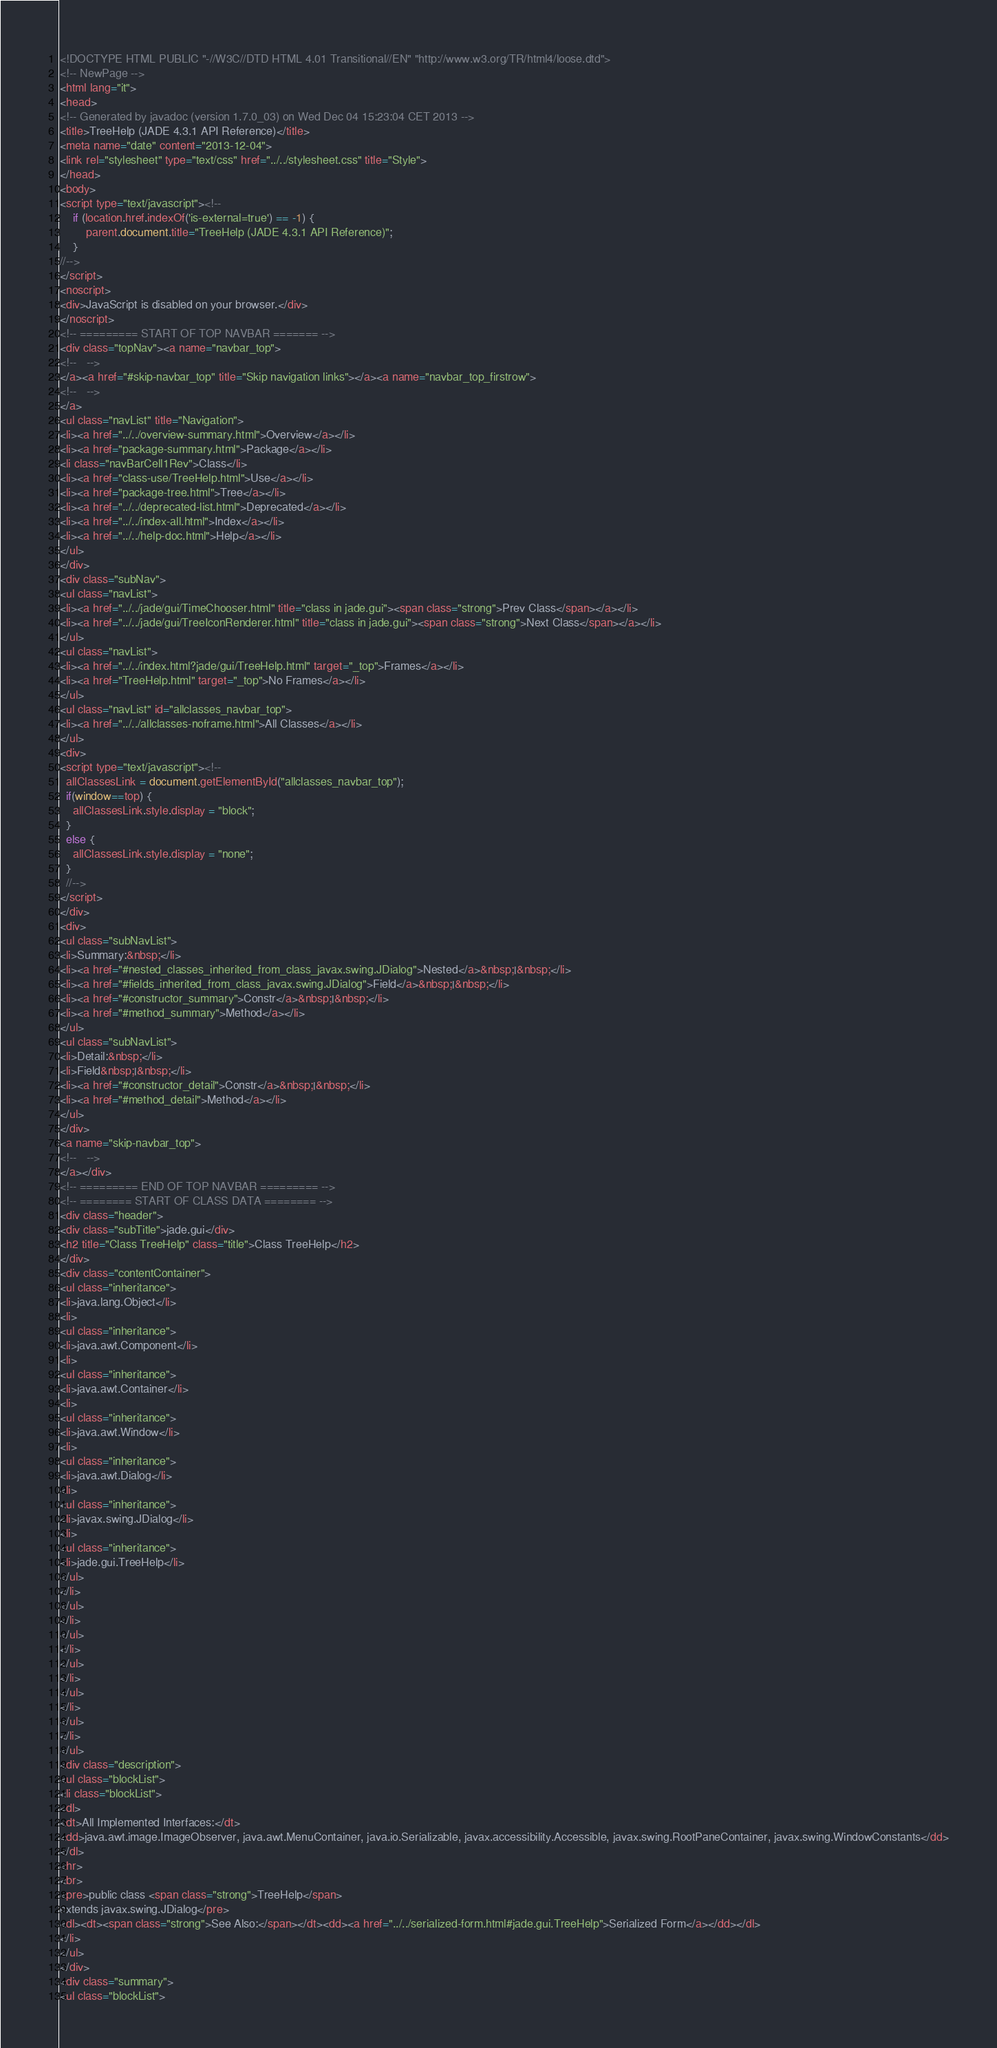<code> <loc_0><loc_0><loc_500><loc_500><_HTML_><!DOCTYPE HTML PUBLIC "-//W3C//DTD HTML 4.01 Transitional//EN" "http://www.w3.org/TR/html4/loose.dtd">
<!-- NewPage -->
<html lang="it">
<head>
<!-- Generated by javadoc (version 1.7.0_03) on Wed Dec 04 15:23:04 CET 2013 -->
<title>TreeHelp (JADE 4.3.1 API Reference)</title>
<meta name="date" content="2013-12-04">
<link rel="stylesheet" type="text/css" href="../../stylesheet.css" title="Style">
</head>
<body>
<script type="text/javascript"><!--
    if (location.href.indexOf('is-external=true') == -1) {
        parent.document.title="TreeHelp (JADE 4.3.1 API Reference)";
    }
//-->
</script>
<noscript>
<div>JavaScript is disabled on your browser.</div>
</noscript>
<!-- ========= START OF TOP NAVBAR ======= -->
<div class="topNav"><a name="navbar_top">
<!--   -->
</a><a href="#skip-navbar_top" title="Skip navigation links"></a><a name="navbar_top_firstrow">
<!--   -->
</a>
<ul class="navList" title="Navigation">
<li><a href="../../overview-summary.html">Overview</a></li>
<li><a href="package-summary.html">Package</a></li>
<li class="navBarCell1Rev">Class</li>
<li><a href="class-use/TreeHelp.html">Use</a></li>
<li><a href="package-tree.html">Tree</a></li>
<li><a href="../../deprecated-list.html">Deprecated</a></li>
<li><a href="../../index-all.html">Index</a></li>
<li><a href="../../help-doc.html">Help</a></li>
</ul>
</div>
<div class="subNav">
<ul class="navList">
<li><a href="../../jade/gui/TimeChooser.html" title="class in jade.gui"><span class="strong">Prev Class</span></a></li>
<li><a href="../../jade/gui/TreeIconRenderer.html" title="class in jade.gui"><span class="strong">Next Class</span></a></li>
</ul>
<ul class="navList">
<li><a href="../../index.html?jade/gui/TreeHelp.html" target="_top">Frames</a></li>
<li><a href="TreeHelp.html" target="_top">No Frames</a></li>
</ul>
<ul class="navList" id="allclasses_navbar_top">
<li><a href="../../allclasses-noframe.html">All Classes</a></li>
</ul>
<div>
<script type="text/javascript"><!--
  allClassesLink = document.getElementById("allclasses_navbar_top");
  if(window==top) {
    allClassesLink.style.display = "block";
  }
  else {
    allClassesLink.style.display = "none";
  }
  //-->
</script>
</div>
<div>
<ul class="subNavList">
<li>Summary:&nbsp;</li>
<li><a href="#nested_classes_inherited_from_class_javax.swing.JDialog">Nested</a>&nbsp;|&nbsp;</li>
<li><a href="#fields_inherited_from_class_javax.swing.JDialog">Field</a>&nbsp;|&nbsp;</li>
<li><a href="#constructor_summary">Constr</a>&nbsp;|&nbsp;</li>
<li><a href="#method_summary">Method</a></li>
</ul>
<ul class="subNavList">
<li>Detail:&nbsp;</li>
<li>Field&nbsp;|&nbsp;</li>
<li><a href="#constructor_detail">Constr</a>&nbsp;|&nbsp;</li>
<li><a href="#method_detail">Method</a></li>
</ul>
</div>
<a name="skip-navbar_top">
<!--   -->
</a></div>
<!-- ========= END OF TOP NAVBAR ========= -->
<!-- ======== START OF CLASS DATA ======== -->
<div class="header">
<div class="subTitle">jade.gui</div>
<h2 title="Class TreeHelp" class="title">Class TreeHelp</h2>
</div>
<div class="contentContainer">
<ul class="inheritance">
<li>java.lang.Object</li>
<li>
<ul class="inheritance">
<li>java.awt.Component</li>
<li>
<ul class="inheritance">
<li>java.awt.Container</li>
<li>
<ul class="inheritance">
<li>java.awt.Window</li>
<li>
<ul class="inheritance">
<li>java.awt.Dialog</li>
<li>
<ul class="inheritance">
<li>javax.swing.JDialog</li>
<li>
<ul class="inheritance">
<li>jade.gui.TreeHelp</li>
</ul>
</li>
</ul>
</li>
</ul>
</li>
</ul>
</li>
</ul>
</li>
</ul>
</li>
</ul>
<div class="description">
<ul class="blockList">
<li class="blockList">
<dl>
<dt>All Implemented Interfaces:</dt>
<dd>java.awt.image.ImageObserver, java.awt.MenuContainer, java.io.Serializable, javax.accessibility.Accessible, javax.swing.RootPaneContainer, javax.swing.WindowConstants</dd>
</dl>
<hr>
<br>
<pre>public class <span class="strong">TreeHelp</span>
extends javax.swing.JDialog</pre>
<dl><dt><span class="strong">See Also:</span></dt><dd><a href="../../serialized-form.html#jade.gui.TreeHelp">Serialized Form</a></dd></dl>
</li>
</ul>
</div>
<div class="summary">
<ul class="blockList"></code> 